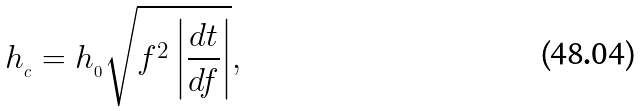<formula> <loc_0><loc_0><loc_500><loc_500>h _ { _ { c } } = h _ { _ { 0 } } \sqrt { f ^ { 2 } \left | \frac { d t } { d f } \right | } ,</formula> 